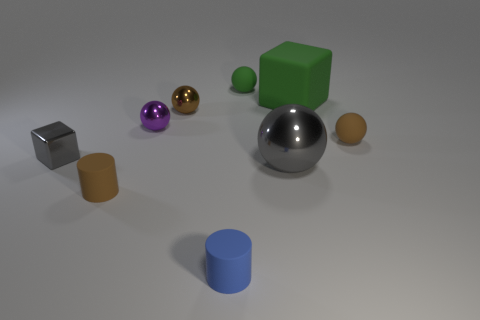Subtract all green balls. How many balls are left? 4 Subtract all tiny purple balls. How many balls are left? 4 Subtract all cubes. How many objects are left? 7 Subtract all purple cubes. Subtract all purple spheres. How many cubes are left? 2 Subtract all cyan blocks. How many purple balls are left? 1 Subtract all big gray shiny cylinders. Subtract all small matte objects. How many objects are left? 5 Add 5 large gray shiny objects. How many large gray shiny objects are left? 6 Add 5 tiny red objects. How many tiny red objects exist? 5 Add 1 tiny green metallic cylinders. How many objects exist? 10 Subtract 0 cyan cylinders. How many objects are left? 9 